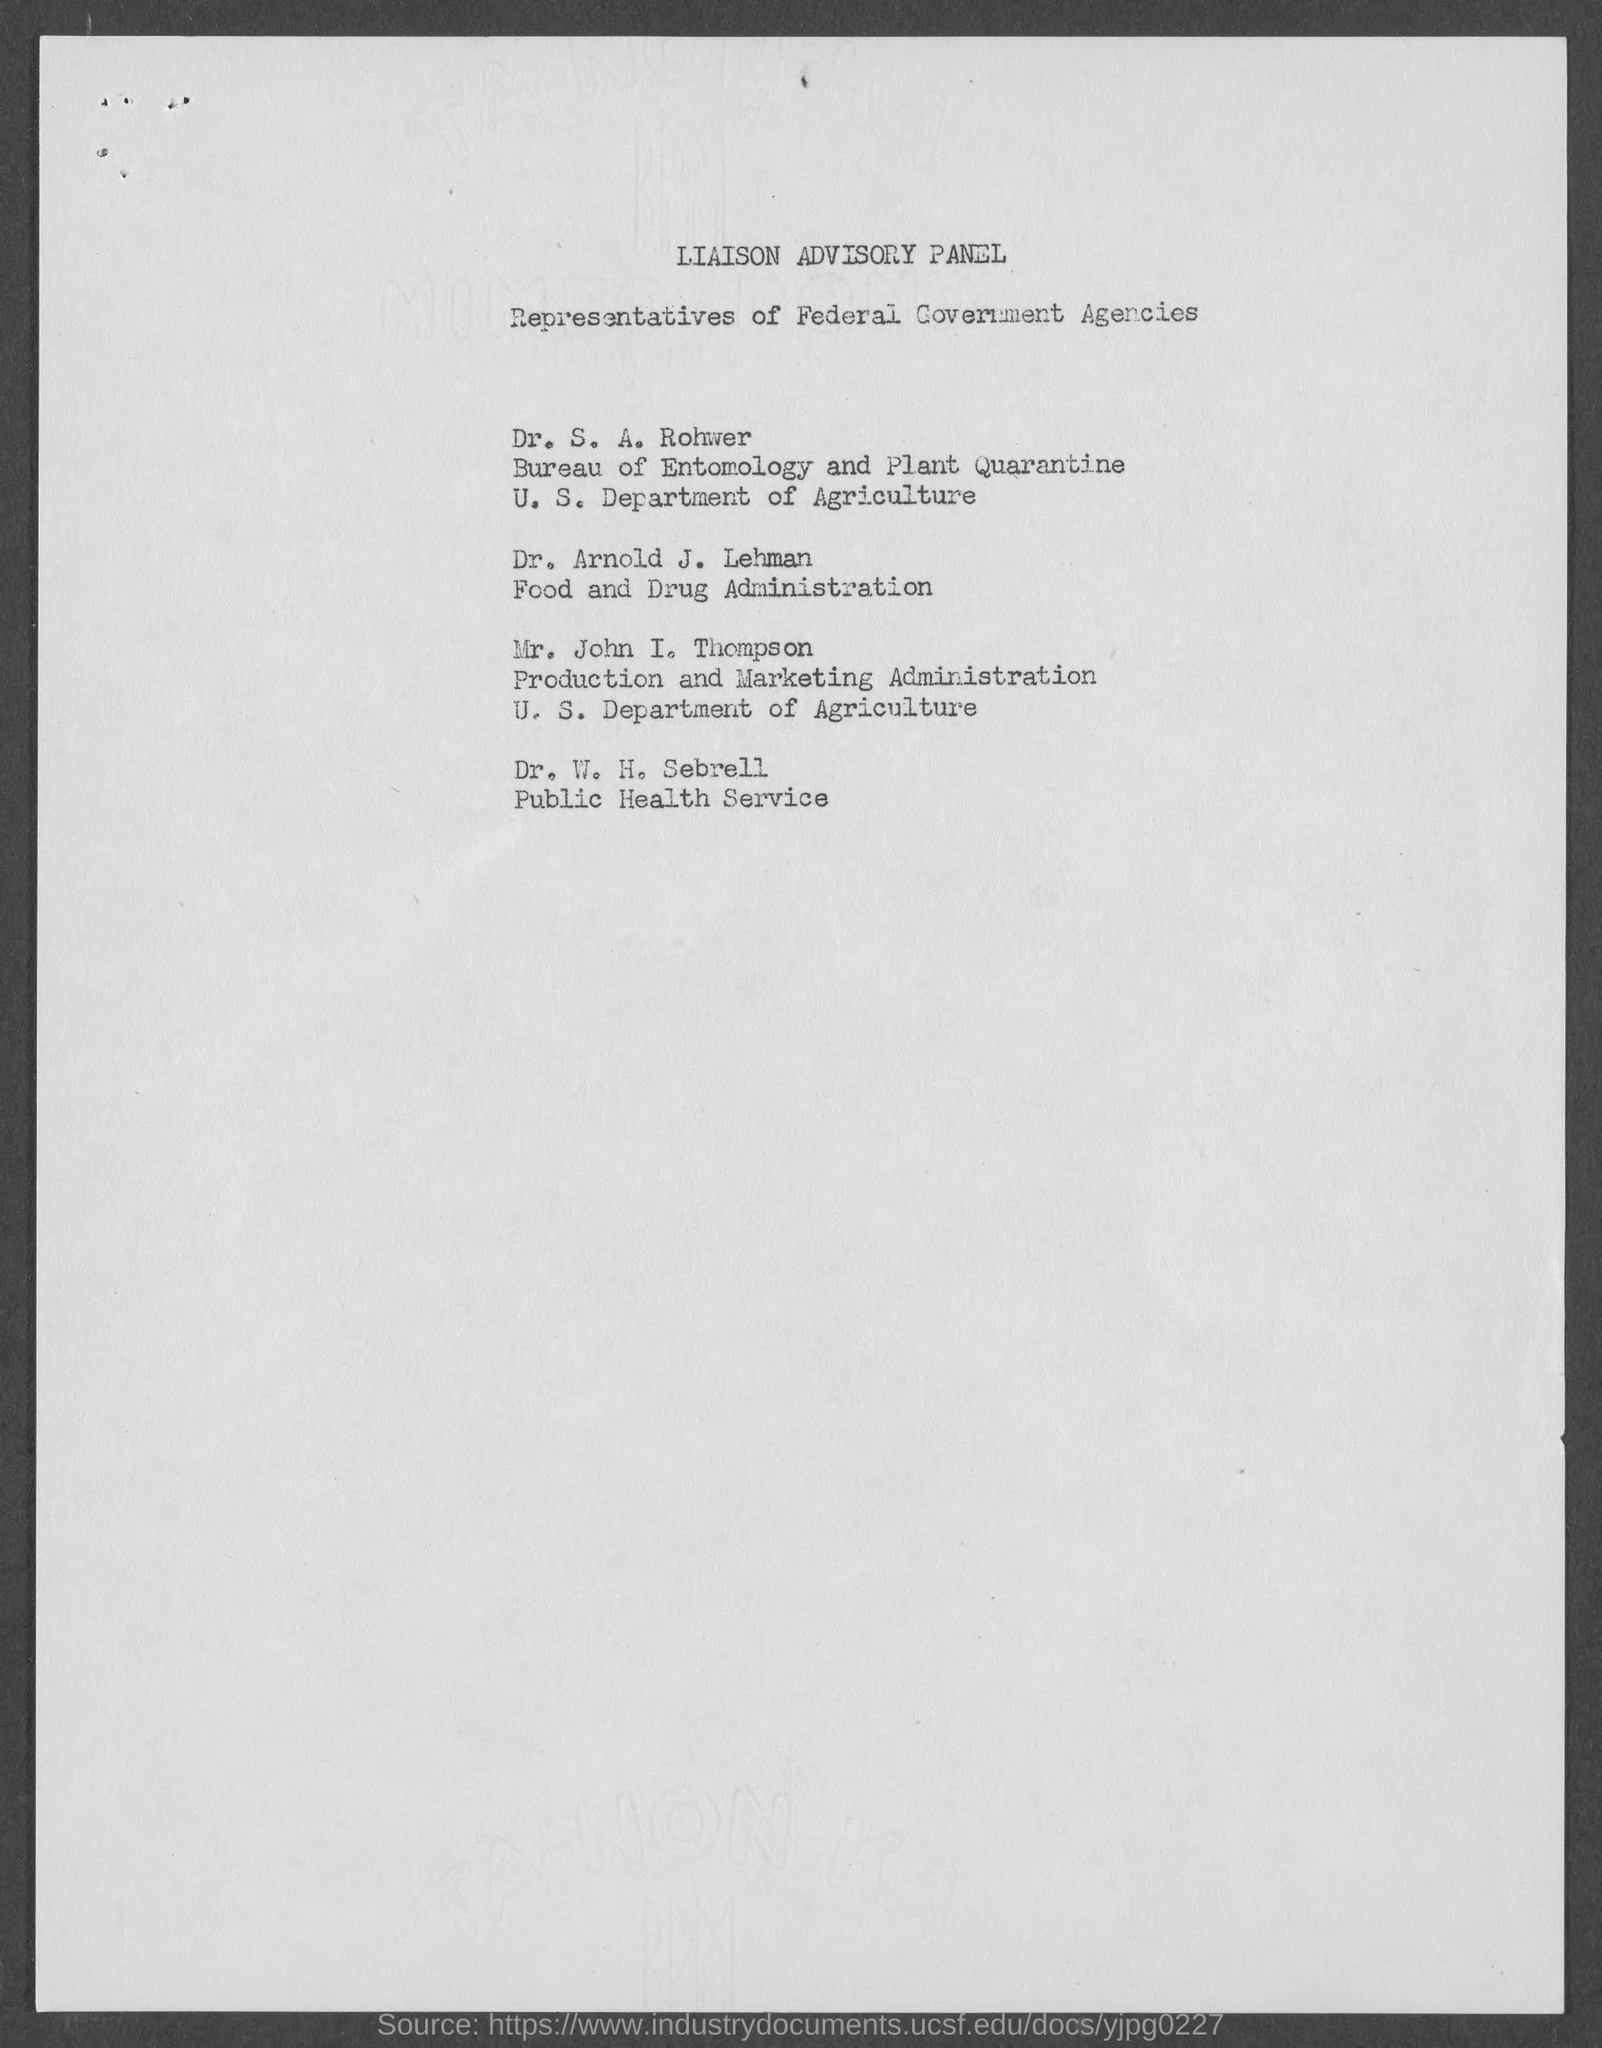List a handful of essential elements in this visual. The document lists representatives of federal government agencies as the persons in question. Dr. Arnold J. Lehman is a member of the Food and Drug Administration. Dr. W. H. Sebrell, who is affiliated with the public health service, is a person of interest. 